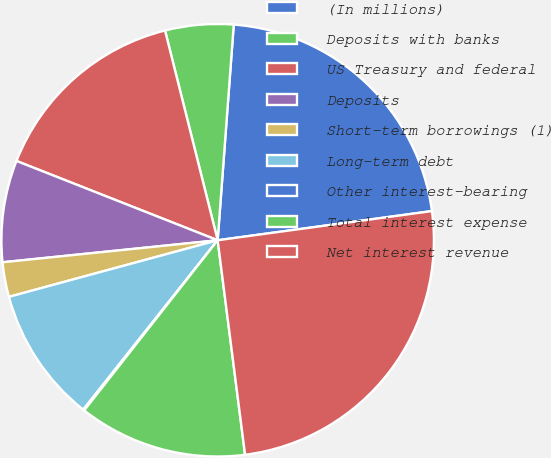Convert chart. <chart><loc_0><loc_0><loc_500><loc_500><pie_chart><fcel>(In millions)<fcel>Deposits with banks<fcel>US Treasury and federal<fcel>Deposits<fcel>Short-term borrowings (1)<fcel>Long-term debt<fcel>Other interest-bearing<fcel>Total interest expense<fcel>Net interest revenue<nl><fcel>21.66%<fcel>5.1%<fcel>15.11%<fcel>7.6%<fcel>2.59%<fcel>10.11%<fcel>0.09%<fcel>12.61%<fcel>25.13%<nl></chart> 